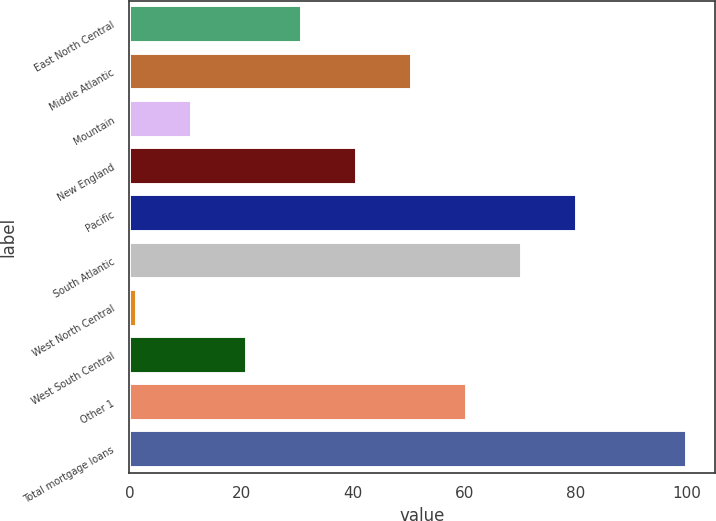Convert chart. <chart><loc_0><loc_0><loc_500><loc_500><bar_chart><fcel>East North Central<fcel>Middle Atlantic<fcel>Mountain<fcel>New England<fcel>Pacific<fcel>South Atlantic<fcel>West North Central<fcel>West South Central<fcel>Other 1<fcel>Total mortgage loans<nl><fcel>30.98<fcel>50.7<fcel>11.26<fcel>40.84<fcel>80.28<fcel>70.42<fcel>1.4<fcel>21.12<fcel>60.56<fcel>100<nl></chart> 